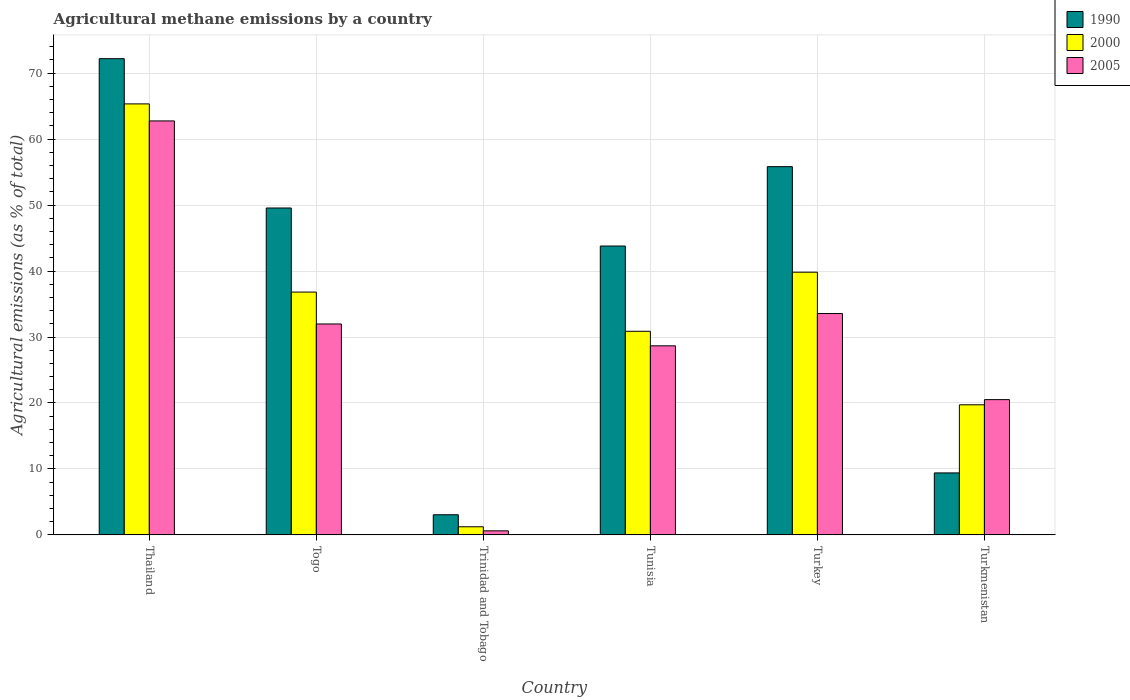Are the number of bars per tick equal to the number of legend labels?
Offer a terse response. Yes. Are the number of bars on each tick of the X-axis equal?
Your answer should be very brief. Yes. How many bars are there on the 5th tick from the right?
Provide a succinct answer. 3. What is the label of the 3rd group of bars from the left?
Ensure brevity in your answer.  Trinidad and Tobago. In how many cases, is the number of bars for a given country not equal to the number of legend labels?
Provide a succinct answer. 0. What is the amount of agricultural methane emitted in 2005 in Tunisia?
Make the answer very short. 28.66. Across all countries, what is the maximum amount of agricultural methane emitted in 2005?
Offer a very short reply. 62.76. Across all countries, what is the minimum amount of agricultural methane emitted in 2005?
Your answer should be very brief. 0.62. In which country was the amount of agricultural methane emitted in 2000 maximum?
Give a very brief answer. Thailand. In which country was the amount of agricultural methane emitted in 1990 minimum?
Your response must be concise. Trinidad and Tobago. What is the total amount of agricultural methane emitted in 2005 in the graph?
Your answer should be compact. 178.08. What is the difference between the amount of agricultural methane emitted in 2005 in Trinidad and Tobago and that in Tunisia?
Keep it short and to the point. -28.05. What is the difference between the amount of agricultural methane emitted in 2005 in Turkmenistan and the amount of agricultural methane emitted in 1990 in Tunisia?
Ensure brevity in your answer.  -23.29. What is the average amount of agricultural methane emitted in 2005 per country?
Make the answer very short. 29.68. What is the difference between the amount of agricultural methane emitted of/in 2005 and amount of agricultural methane emitted of/in 1990 in Turkmenistan?
Keep it short and to the point. 11.11. What is the ratio of the amount of agricultural methane emitted in 2000 in Togo to that in Turkmenistan?
Offer a very short reply. 1.87. Is the amount of agricultural methane emitted in 2005 in Thailand less than that in Togo?
Offer a terse response. No. What is the difference between the highest and the second highest amount of agricultural methane emitted in 1990?
Provide a succinct answer. 22.63. What is the difference between the highest and the lowest amount of agricultural methane emitted in 1990?
Your answer should be very brief. 69.14. What does the 2nd bar from the left in Turkey represents?
Provide a short and direct response. 2000. Are all the bars in the graph horizontal?
Your response must be concise. No. Are the values on the major ticks of Y-axis written in scientific E-notation?
Provide a short and direct response. No. Does the graph contain any zero values?
Keep it short and to the point. No. How many legend labels are there?
Offer a terse response. 3. How are the legend labels stacked?
Your answer should be compact. Vertical. What is the title of the graph?
Your answer should be very brief. Agricultural methane emissions by a country. Does "1965" appear as one of the legend labels in the graph?
Your answer should be very brief. No. What is the label or title of the X-axis?
Keep it short and to the point. Country. What is the label or title of the Y-axis?
Provide a short and direct response. Agricultural emissions (as % of total). What is the Agricultural emissions (as % of total) of 1990 in Thailand?
Make the answer very short. 72.19. What is the Agricultural emissions (as % of total) of 2000 in Thailand?
Your answer should be compact. 65.34. What is the Agricultural emissions (as % of total) of 2005 in Thailand?
Provide a short and direct response. 62.76. What is the Agricultural emissions (as % of total) in 1990 in Togo?
Give a very brief answer. 49.56. What is the Agricultural emissions (as % of total) of 2000 in Togo?
Offer a very short reply. 36.81. What is the Agricultural emissions (as % of total) in 2005 in Togo?
Provide a succinct answer. 31.98. What is the Agricultural emissions (as % of total) of 1990 in Trinidad and Tobago?
Make the answer very short. 3.05. What is the Agricultural emissions (as % of total) in 2000 in Trinidad and Tobago?
Provide a succinct answer. 1.23. What is the Agricultural emissions (as % of total) in 2005 in Trinidad and Tobago?
Provide a short and direct response. 0.62. What is the Agricultural emissions (as % of total) in 1990 in Tunisia?
Your response must be concise. 43.79. What is the Agricultural emissions (as % of total) of 2000 in Tunisia?
Ensure brevity in your answer.  30.87. What is the Agricultural emissions (as % of total) in 2005 in Tunisia?
Make the answer very short. 28.66. What is the Agricultural emissions (as % of total) in 1990 in Turkey?
Keep it short and to the point. 55.83. What is the Agricultural emissions (as % of total) in 2000 in Turkey?
Ensure brevity in your answer.  39.83. What is the Agricultural emissions (as % of total) of 2005 in Turkey?
Make the answer very short. 33.56. What is the Agricultural emissions (as % of total) in 1990 in Turkmenistan?
Offer a terse response. 9.4. What is the Agricultural emissions (as % of total) of 2000 in Turkmenistan?
Give a very brief answer. 19.72. What is the Agricultural emissions (as % of total) of 2005 in Turkmenistan?
Provide a succinct answer. 20.51. Across all countries, what is the maximum Agricultural emissions (as % of total) of 1990?
Offer a very short reply. 72.19. Across all countries, what is the maximum Agricultural emissions (as % of total) of 2000?
Give a very brief answer. 65.34. Across all countries, what is the maximum Agricultural emissions (as % of total) in 2005?
Offer a very short reply. 62.76. Across all countries, what is the minimum Agricultural emissions (as % of total) of 1990?
Offer a terse response. 3.05. Across all countries, what is the minimum Agricultural emissions (as % of total) in 2000?
Your answer should be very brief. 1.23. Across all countries, what is the minimum Agricultural emissions (as % of total) of 2005?
Provide a short and direct response. 0.62. What is the total Agricultural emissions (as % of total) of 1990 in the graph?
Ensure brevity in your answer.  233.82. What is the total Agricultural emissions (as % of total) of 2000 in the graph?
Your response must be concise. 193.8. What is the total Agricultural emissions (as % of total) in 2005 in the graph?
Your response must be concise. 178.08. What is the difference between the Agricultural emissions (as % of total) in 1990 in Thailand and that in Togo?
Provide a short and direct response. 22.63. What is the difference between the Agricultural emissions (as % of total) of 2000 in Thailand and that in Togo?
Provide a succinct answer. 28.53. What is the difference between the Agricultural emissions (as % of total) in 2005 in Thailand and that in Togo?
Offer a very short reply. 30.78. What is the difference between the Agricultural emissions (as % of total) of 1990 in Thailand and that in Trinidad and Tobago?
Make the answer very short. 69.14. What is the difference between the Agricultural emissions (as % of total) in 2000 in Thailand and that in Trinidad and Tobago?
Offer a very short reply. 64.11. What is the difference between the Agricultural emissions (as % of total) in 2005 in Thailand and that in Trinidad and Tobago?
Your response must be concise. 62.14. What is the difference between the Agricultural emissions (as % of total) of 1990 in Thailand and that in Tunisia?
Keep it short and to the point. 28.4. What is the difference between the Agricultural emissions (as % of total) in 2000 in Thailand and that in Tunisia?
Ensure brevity in your answer.  34.47. What is the difference between the Agricultural emissions (as % of total) of 2005 in Thailand and that in Tunisia?
Make the answer very short. 34.09. What is the difference between the Agricultural emissions (as % of total) of 1990 in Thailand and that in Turkey?
Keep it short and to the point. 16.37. What is the difference between the Agricultural emissions (as % of total) in 2000 in Thailand and that in Turkey?
Give a very brief answer. 25.51. What is the difference between the Agricultural emissions (as % of total) of 2005 in Thailand and that in Turkey?
Provide a succinct answer. 29.2. What is the difference between the Agricultural emissions (as % of total) of 1990 in Thailand and that in Turkmenistan?
Your response must be concise. 62.8. What is the difference between the Agricultural emissions (as % of total) of 2000 in Thailand and that in Turkmenistan?
Your answer should be compact. 45.62. What is the difference between the Agricultural emissions (as % of total) of 2005 in Thailand and that in Turkmenistan?
Your answer should be very brief. 42.25. What is the difference between the Agricultural emissions (as % of total) in 1990 in Togo and that in Trinidad and Tobago?
Give a very brief answer. 46.51. What is the difference between the Agricultural emissions (as % of total) in 2000 in Togo and that in Trinidad and Tobago?
Offer a terse response. 35.58. What is the difference between the Agricultural emissions (as % of total) of 2005 in Togo and that in Trinidad and Tobago?
Offer a very short reply. 31.36. What is the difference between the Agricultural emissions (as % of total) in 1990 in Togo and that in Tunisia?
Ensure brevity in your answer.  5.77. What is the difference between the Agricultural emissions (as % of total) of 2000 in Togo and that in Tunisia?
Make the answer very short. 5.95. What is the difference between the Agricultural emissions (as % of total) in 2005 in Togo and that in Tunisia?
Keep it short and to the point. 3.31. What is the difference between the Agricultural emissions (as % of total) in 1990 in Togo and that in Turkey?
Keep it short and to the point. -6.27. What is the difference between the Agricultural emissions (as % of total) of 2000 in Togo and that in Turkey?
Offer a very short reply. -3.01. What is the difference between the Agricultural emissions (as % of total) in 2005 in Togo and that in Turkey?
Give a very brief answer. -1.58. What is the difference between the Agricultural emissions (as % of total) in 1990 in Togo and that in Turkmenistan?
Your response must be concise. 40.16. What is the difference between the Agricultural emissions (as % of total) of 2000 in Togo and that in Turkmenistan?
Provide a short and direct response. 17.09. What is the difference between the Agricultural emissions (as % of total) of 2005 in Togo and that in Turkmenistan?
Your answer should be compact. 11.47. What is the difference between the Agricultural emissions (as % of total) of 1990 in Trinidad and Tobago and that in Tunisia?
Provide a succinct answer. -40.74. What is the difference between the Agricultural emissions (as % of total) of 2000 in Trinidad and Tobago and that in Tunisia?
Ensure brevity in your answer.  -29.64. What is the difference between the Agricultural emissions (as % of total) of 2005 in Trinidad and Tobago and that in Tunisia?
Offer a very short reply. -28.05. What is the difference between the Agricultural emissions (as % of total) of 1990 in Trinidad and Tobago and that in Turkey?
Keep it short and to the point. -52.78. What is the difference between the Agricultural emissions (as % of total) in 2000 in Trinidad and Tobago and that in Turkey?
Keep it short and to the point. -38.6. What is the difference between the Agricultural emissions (as % of total) in 2005 in Trinidad and Tobago and that in Turkey?
Your answer should be very brief. -32.94. What is the difference between the Agricultural emissions (as % of total) of 1990 in Trinidad and Tobago and that in Turkmenistan?
Provide a succinct answer. -6.35. What is the difference between the Agricultural emissions (as % of total) in 2000 in Trinidad and Tobago and that in Turkmenistan?
Offer a very short reply. -18.49. What is the difference between the Agricultural emissions (as % of total) in 2005 in Trinidad and Tobago and that in Turkmenistan?
Provide a short and direct response. -19.89. What is the difference between the Agricultural emissions (as % of total) of 1990 in Tunisia and that in Turkey?
Give a very brief answer. -12.03. What is the difference between the Agricultural emissions (as % of total) in 2000 in Tunisia and that in Turkey?
Keep it short and to the point. -8.96. What is the difference between the Agricultural emissions (as % of total) in 2005 in Tunisia and that in Turkey?
Ensure brevity in your answer.  -4.9. What is the difference between the Agricultural emissions (as % of total) in 1990 in Tunisia and that in Turkmenistan?
Offer a terse response. 34.4. What is the difference between the Agricultural emissions (as % of total) in 2000 in Tunisia and that in Turkmenistan?
Your answer should be compact. 11.14. What is the difference between the Agricultural emissions (as % of total) of 2005 in Tunisia and that in Turkmenistan?
Make the answer very short. 8.16. What is the difference between the Agricultural emissions (as % of total) in 1990 in Turkey and that in Turkmenistan?
Provide a short and direct response. 46.43. What is the difference between the Agricultural emissions (as % of total) of 2000 in Turkey and that in Turkmenistan?
Your response must be concise. 20.11. What is the difference between the Agricultural emissions (as % of total) of 2005 in Turkey and that in Turkmenistan?
Provide a short and direct response. 13.05. What is the difference between the Agricultural emissions (as % of total) in 1990 in Thailand and the Agricultural emissions (as % of total) in 2000 in Togo?
Offer a very short reply. 35.38. What is the difference between the Agricultural emissions (as % of total) in 1990 in Thailand and the Agricultural emissions (as % of total) in 2005 in Togo?
Make the answer very short. 40.22. What is the difference between the Agricultural emissions (as % of total) of 2000 in Thailand and the Agricultural emissions (as % of total) of 2005 in Togo?
Keep it short and to the point. 33.36. What is the difference between the Agricultural emissions (as % of total) of 1990 in Thailand and the Agricultural emissions (as % of total) of 2000 in Trinidad and Tobago?
Make the answer very short. 70.96. What is the difference between the Agricultural emissions (as % of total) in 1990 in Thailand and the Agricultural emissions (as % of total) in 2005 in Trinidad and Tobago?
Provide a succinct answer. 71.58. What is the difference between the Agricultural emissions (as % of total) of 2000 in Thailand and the Agricultural emissions (as % of total) of 2005 in Trinidad and Tobago?
Offer a terse response. 64.72. What is the difference between the Agricultural emissions (as % of total) of 1990 in Thailand and the Agricultural emissions (as % of total) of 2000 in Tunisia?
Your answer should be very brief. 41.33. What is the difference between the Agricultural emissions (as % of total) in 1990 in Thailand and the Agricultural emissions (as % of total) in 2005 in Tunisia?
Keep it short and to the point. 43.53. What is the difference between the Agricultural emissions (as % of total) of 2000 in Thailand and the Agricultural emissions (as % of total) of 2005 in Tunisia?
Give a very brief answer. 36.68. What is the difference between the Agricultural emissions (as % of total) in 1990 in Thailand and the Agricultural emissions (as % of total) in 2000 in Turkey?
Offer a very short reply. 32.37. What is the difference between the Agricultural emissions (as % of total) in 1990 in Thailand and the Agricultural emissions (as % of total) in 2005 in Turkey?
Your response must be concise. 38.64. What is the difference between the Agricultural emissions (as % of total) in 2000 in Thailand and the Agricultural emissions (as % of total) in 2005 in Turkey?
Your response must be concise. 31.78. What is the difference between the Agricultural emissions (as % of total) of 1990 in Thailand and the Agricultural emissions (as % of total) of 2000 in Turkmenistan?
Offer a very short reply. 52.47. What is the difference between the Agricultural emissions (as % of total) in 1990 in Thailand and the Agricultural emissions (as % of total) in 2005 in Turkmenistan?
Your answer should be compact. 51.69. What is the difference between the Agricultural emissions (as % of total) of 2000 in Thailand and the Agricultural emissions (as % of total) of 2005 in Turkmenistan?
Provide a short and direct response. 44.83. What is the difference between the Agricultural emissions (as % of total) of 1990 in Togo and the Agricultural emissions (as % of total) of 2000 in Trinidad and Tobago?
Offer a very short reply. 48.33. What is the difference between the Agricultural emissions (as % of total) of 1990 in Togo and the Agricultural emissions (as % of total) of 2005 in Trinidad and Tobago?
Give a very brief answer. 48.94. What is the difference between the Agricultural emissions (as % of total) of 2000 in Togo and the Agricultural emissions (as % of total) of 2005 in Trinidad and Tobago?
Keep it short and to the point. 36.2. What is the difference between the Agricultural emissions (as % of total) in 1990 in Togo and the Agricultural emissions (as % of total) in 2000 in Tunisia?
Your answer should be very brief. 18.69. What is the difference between the Agricultural emissions (as % of total) of 1990 in Togo and the Agricultural emissions (as % of total) of 2005 in Tunisia?
Offer a terse response. 20.9. What is the difference between the Agricultural emissions (as % of total) in 2000 in Togo and the Agricultural emissions (as % of total) in 2005 in Tunisia?
Provide a short and direct response. 8.15. What is the difference between the Agricultural emissions (as % of total) in 1990 in Togo and the Agricultural emissions (as % of total) in 2000 in Turkey?
Keep it short and to the point. 9.73. What is the difference between the Agricultural emissions (as % of total) in 1990 in Togo and the Agricultural emissions (as % of total) in 2005 in Turkey?
Give a very brief answer. 16. What is the difference between the Agricultural emissions (as % of total) in 2000 in Togo and the Agricultural emissions (as % of total) in 2005 in Turkey?
Your answer should be compact. 3.25. What is the difference between the Agricultural emissions (as % of total) of 1990 in Togo and the Agricultural emissions (as % of total) of 2000 in Turkmenistan?
Provide a succinct answer. 29.84. What is the difference between the Agricultural emissions (as % of total) in 1990 in Togo and the Agricultural emissions (as % of total) in 2005 in Turkmenistan?
Your answer should be compact. 29.05. What is the difference between the Agricultural emissions (as % of total) in 2000 in Togo and the Agricultural emissions (as % of total) in 2005 in Turkmenistan?
Offer a terse response. 16.31. What is the difference between the Agricultural emissions (as % of total) of 1990 in Trinidad and Tobago and the Agricultural emissions (as % of total) of 2000 in Tunisia?
Keep it short and to the point. -27.81. What is the difference between the Agricultural emissions (as % of total) of 1990 in Trinidad and Tobago and the Agricultural emissions (as % of total) of 2005 in Tunisia?
Ensure brevity in your answer.  -25.61. What is the difference between the Agricultural emissions (as % of total) of 2000 in Trinidad and Tobago and the Agricultural emissions (as % of total) of 2005 in Tunisia?
Offer a very short reply. -27.43. What is the difference between the Agricultural emissions (as % of total) of 1990 in Trinidad and Tobago and the Agricultural emissions (as % of total) of 2000 in Turkey?
Your answer should be compact. -36.78. What is the difference between the Agricultural emissions (as % of total) of 1990 in Trinidad and Tobago and the Agricultural emissions (as % of total) of 2005 in Turkey?
Offer a terse response. -30.51. What is the difference between the Agricultural emissions (as % of total) in 2000 in Trinidad and Tobago and the Agricultural emissions (as % of total) in 2005 in Turkey?
Offer a very short reply. -32.33. What is the difference between the Agricultural emissions (as % of total) in 1990 in Trinidad and Tobago and the Agricultural emissions (as % of total) in 2000 in Turkmenistan?
Your answer should be compact. -16.67. What is the difference between the Agricultural emissions (as % of total) in 1990 in Trinidad and Tobago and the Agricultural emissions (as % of total) in 2005 in Turkmenistan?
Your answer should be compact. -17.46. What is the difference between the Agricultural emissions (as % of total) in 2000 in Trinidad and Tobago and the Agricultural emissions (as % of total) in 2005 in Turkmenistan?
Make the answer very short. -19.28. What is the difference between the Agricultural emissions (as % of total) in 1990 in Tunisia and the Agricultural emissions (as % of total) in 2000 in Turkey?
Ensure brevity in your answer.  3.97. What is the difference between the Agricultural emissions (as % of total) in 1990 in Tunisia and the Agricultural emissions (as % of total) in 2005 in Turkey?
Ensure brevity in your answer.  10.23. What is the difference between the Agricultural emissions (as % of total) in 2000 in Tunisia and the Agricultural emissions (as % of total) in 2005 in Turkey?
Keep it short and to the point. -2.69. What is the difference between the Agricultural emissions (as % of total) of 1990 in Tunisia and the Agricultural emissions (as % of total) of 2000 in Turkmenistan?
Your response must be concise. 24.07. What is the difference between the Agricultural emissions (as % of total) in 1990 in Tunisia and the Agricultural emissions (as % of total) in 2005 in Turkmenistan?
Ensure brevity in your answer.  23.29. What is the difference between the Agricultural emissions (as % of total) of 2000 in Tunisia and the Agricultural emissions (as % of total) of 2005 in Turkmenistan?
Provide a short and direct response. 10.36. What is the difference between the Agricultural emissions (as % of total) in 1990 in Turkey and the Agricultural emissions (as % of total) in 2000 in Turkmenistan?
Provide a succinct answer. 36.11. What is the difference between the Agricultural emissions (as % of total) in 1990 in Turkey and the Agricultural emissions (as % of total) in 2005 in Turkmenistan?
Provide a succinct answer. 35.32. What is the difference between the Agricultural emissions (as % of total) in 2000 in Turkey and the Agricultural emissions (as % of total) in 2005 in Turkmenistan?
Keep it short and to the point. 19.32. What is the average Agricultural emissions (as % of total) in 1990 per country?
Provide a short and direct response. 38.97. What is the average Agricultural emissions (as % of total) in 2000 per country?
Offer a very short reply. 32.3. What is the average Agricultural emissions (as % of total) in 2005 per country?
Keep it short and to the point. 29.68. What is the difference between the Agricultural emissions (as % of total) in 1990 and Agricultural emissions (as % of total) in 2000 in Thailand?
Provide a succinct answer. 6.85. What is the difference between the Agricultural emissions (as % of total) in 1990 and Agricultural emissions (as % of total) in 2005 in Thailand?
Keep it short and to the point. 9.44. What is the difference between the Agricultural emissions (as % of total) in 2000 and Agricultural emissions (as % of total) in 2005 in Thailand?
Give a very brief answer. 2.58. What is the difference between the Agricultural emissions (as % of total) of 1990 and Agricultural emissions (as % of total) of 2000 in Togo?
Your answer should be very brief. 12.75. What is the difference between the Agricultural emissions (as % of total) in 1990 and Agricultural emissions (as % of total) in 2005 in Togo?
Provide a short and direct response. 17.58. What is the difference between the Agricultural emissions (as % of total) in 2000 and Agricultural emissions (as % of total) in 2005 in Togo?
Provide a succinct answer. 4.84. What is the difference between the Agricultural emissions (as % of total) in 1990 and Agricultural emissions (as % of total) in 2000 in Trinidad and Tobago?
Offer a terse response. 1.82. What is the difference between the Agricultural emissions (as % of total) of 1990 and Agricultural emissions (as % of total) of 2005 in Trinidad and Tobago?
Give a very brief answer. 2.44. What is the difference between the Agricultural emissions (as % of total) in 2000 and Agricultural emissions (as % of total) in 2005 in Trinidad and Tobago?
Give a very brief answer. 0.61. What is the difference between the Agricultural emissions (as % of total) in 1990 and Agricultural emissions (as % of total) in 2000 in Tunisia?
Your answer should be compact. 12.93. What is the difference between the Agricultural emissions (as % of total) in 1990 and Agricultural emissions (as % of total) in 2005 in Tunisia?
Offer a terse response. 15.13. What is the difference between the Agricultural emissions (as % of total) of 2000 and Agricultural emissions (as % of total) of 2005 in Tunisia?
Ensure brevity in your answer.  2.2. What is the difference between the Agricultural emissions (as % of total) of 1990 and Agricultural emissions (as % of total) of 2000 in Turkey?
Your response must be concise. 16. What is the difference between the Agricultural emissions (as % of total) of 1990 and Agricultural emissions (as % of total) of 2005 in Turkey?
Offer a very short reply. 22.27. What is the difference between the Agricultural emissions (as % of total) in 2000 and Agricultural emissions (as % of total) in 2005 in Turkey?
Offer a very short reply. 6.27. What is the difference between the Agricultural emissions (as % of total) in 1990 and Agricultural emissions (as % of total) in 2000 in Turkmenistan?
Your answer should be very brief. -10.32. What is the difference between the Agricultural emissions (as % of total) of 1990 and Agricultural emissions (as % of total) of 2005 in Turkmenistan?
Provide a short and direct response. -11.11. What is the difference between the Agricultural emissions (as % of total) in 2000 and Agricultural emissions (as % of total) in 2005 in Turkmenistan?
Offer a very short reply. -0.79. What is the ratio of the Agricultural emissions (as % of total) in 1990 in Thailand to that in Togo?
Provide a short and direct response. 1.46. What is the ratio of the Agricultural emissions (as % of total) in 2000 in Thailand to that in Togo?
Make the answer very short. 1.77. What is the ratio of the Agricultural emissions (as % of total) of 2005 in Thailand to that in Togo?
Offer a terse response. 1.96. What is the ratio of the Agricultural emissions (as % of total) of 1990 in Thailand to that in Trinidad and Tobago?
Your answer should be compact. 23.66. What is the ratio of the Agricultural emissions (as % of total) in 2000 in Thailand to that in Trinidad and Tobago?
Provide a succinct answer. 53.11. What is the ratio of the Agricultural emissions (as % of total) in 2005 in Thailand to that in Trinidad and Tobago?
Your response must be concise. 101.88. What is the ratio of the Agricultural emissions (as % of total) in 1990 in Thailand to that in Tunisia?
Your response must be concise. 1.65. What is the ratio of the Agricultural emissions (as % of total) of 2000 in Thailand to that in Tunisia?
Ensure brevity in your answer.  2.12. What is the ratio of the Agricultural emissions (as % of total) in 2005 in Thailand to that in Tunisia?
Offer a terse response. 2.19. What is the ratio of the Agricultural emissions (as % of total) of 1990 in Thailand to that in Turkey?
Your answer should be very brief. 1.29. What is the ratio of the Agricultural emissions (as % of total) of 2000 in Thailand to that in Turkey?
Keep it short and to the point. 1.64. What is the ratio of the Agricultural emissions (as % of total) of 2005 in Thailand to that in Turkey?
Provide a short and direct response. 1.87. What is the ratio of the Agricultural emissions (as % of total) in 1990 in Thailand to that in Turkmenistan?
Keep it short and to the point. 7.68. What is the ratio of the Agricultural emissions (as % of total) of 2000 in Thailand to that in Turkmenistan?
Your response must be concise. 3.31. What is the ratio of the Agricultural emissions (as % of total) in 2005 in Thailand to that in Turkmenistan?
Give a very brief answer. 3.06. What is the ratio of the Agricultural emissions (as % of total) in 1990 in Togo to that in Trinidad and Tobago?
Ensure brevity in your answer.  16.24. What is the ratio of the Agricultural emissions (as % of total) of 2000 in Togo to that in Trinidad and Tobago?
Provide a succinct answer. 29.92. What is the ratio of the Agricultural emissions (as % of total) in 2005 in Togo to that in Trinidad and Tobago?
Offer a very short reply. 51.91. What is the ratio of the Agricultural emissions (as % of total) of 1990 in Togo to that in Tunisia?
Your response must be concise. 1.13. What is the ratio of the Agricultural emissions (as % of total) in 2000 in Togo to that in Tunisia?
Give a very brief answer. 1.19. What is the ratio of the Agricultural emissions (as % of total) of 2005 in Togo to that in Tunisia?
Make the answer very short. 1.12. What is the ratio of the Agricultural emissions (as % of total) of 1990 in Togo to that in Turkey?
Your answer should be very brief. 0.89. What is the ratio of the Agricultural emissions (as % of total) in 2000 in Togo to that in Turkey?
Provide a succinct answer. 0.92. What is the ratio of the Agricultural emissions (as % of total) in 2005 in Togo to that in Turkey?
Provide a short and direct response. 0.95. What is the ratio of the Agricultural emissions (as % of total) of 1990 in Togo to that in Turkmenistan?
Offer a very short reply. 5.27. What is the ratio of the Agricultural emissions (as % of total) of 2000 in Togo to that in Turkmenistan?
Provide a succinct answer. 1.87. What is the ratio of the Agricultural emissions (as % of total) of 2005 in Togo to that in Turkmenistan?
Make the answer very short. 1.56. What is the ratio of the Agricultural emissions (as % of total) of 1990 in Trinidad and Tobago to that in Tunisia?
Provide a succinct answer. 0.07. What is the ratio of the Agricultural emissions (as % of total) in 2000 in Trinidad and Tobago to that in Tunisia?
Provide a short and direct response. 0.04. What is the ratio of the Agricultural emissions (as % of total) in 2005 in Trinidad and Tobago to that in Tunisia?
Your response must be concise. 0.02. What is the ratio of the Agricultural emissions (as % of total) in 1990 in Trinidad and Tobago to that in Turkey?
Keep it short and to the point. 0.05. What is the ratio of the Agricultural emissions (as % of total) of 2000 in Trinidad and Tobago to that in Turkey?
Provide a succinct answer. 0.03. What is the ratio of the Agricultural emissions (as % of total) of 2005 in Trinidad and Tobago to that in Turkey?
Provide a succinct answer. 0.02. What is the ratio of the Agricultural emissions (as % of total) in 1990 in Trinidad and Tobago to that in Turkmenistan?
Provide a short and direct response. 0.32. What is the ratio of the Agricultural emissions (as % of total) of 2000 in Trinidad and Tobago to that in Turkmenistan?
Provide a short and direct response. 0.06. What is the ratio of the Agricultural emissions (as % of total) in 1990 in Tunisia to that in Turkey?
Keep it short and to the point. 0.78. What is the ratio of the Agricultural emissions (as % of total) of 2000 in Tunisia to that in Turkey?
Offer a terse response. 0.78. What is the ratio of the Agricultural emissions (as % of total) in 2005 in Tunisia to that in Turkey?
Offer a terse response. 0.85. What is the ratio of the Agricultural emissions (as % of total) of 1990 in Tunisia to that in Turkmenistan?
Give a very brief answer. 4.66. What is the ratio of the Agricultural emissions (as % of total) in 2000 in Tunisia to that in Turkmenistan?
Keep it short and to the point. 1.57. What is the ratio of the Agricultural emissions (as % of total) of 2005 in Tunisia to that in Turkmenistan?
Your answer should be very brief. 1.4. What is the ratio of the Agricultural emissions (as % of total) in 1990 in Turkey to that in Turkmenistan?
Your answer should be very brief. 5.94. What is the ratio of the Agricultural emissions (as % of total) of 2000 in Turkey to that in Turkmenistan?
Your response must be concise. 2.02. What is the ratio of the Agricultural emissions (as % of total) of 2005 in Turkey to that in Turkmenistan?
Your answer should be very brief. 1.64. What is the difference between the highest and the second highest Agricultural emissions (as % of total) of 1990?
Give a very brief answer. 16.37. What is the difference between the highest and the second highest Agricultural emissions (as % of total) of 2000?
Your answer should be compact. 25.51. What is the difference between the highest and the second highest Agricultural emissions (as % of total) in 2005?
Ensure brevity in your answer.  29.2. What is the difference between the highest and the lowest Agricultural emissions (as % of total) of 1990?
Your answer should be compact. 69.14. What is the difference between the highest and the lowest Agricultural emissions (as % of total) of 2000?
Your response must be concise. 64.11. What is the difference between the highest and the lowest Agricultural emissions (as % of total) in 2005?
Give a very brief answer. 62.14. 